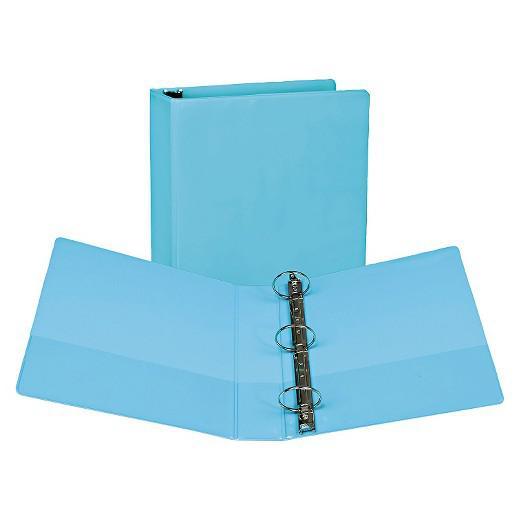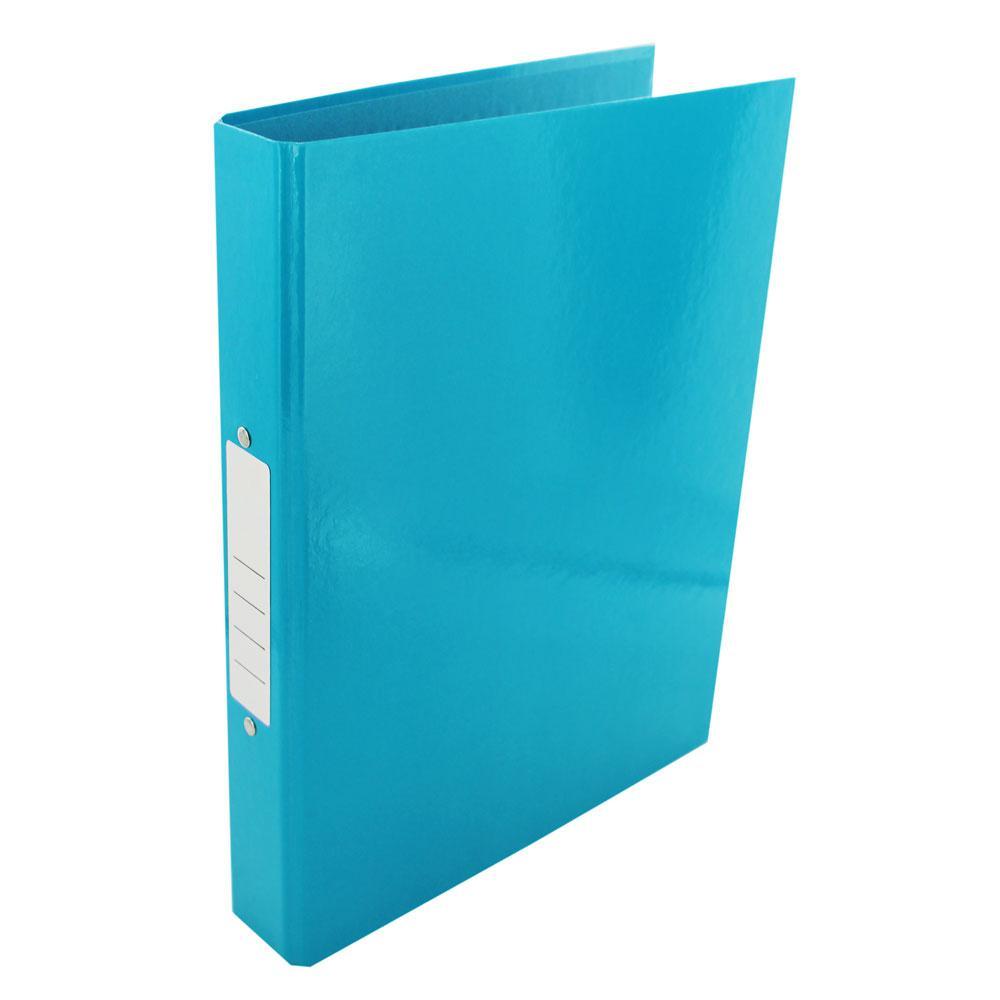The first image is the image on the left, the second image is the image on the right. Examine the images to the left and right. Is the description "In one image a blue notebook is standing on end, while the other image shows more than one notebook." accurate? Answer yes or no. Yes. The first image is the image on the left, the second image is the image on the right. Examine the images to the left and right. Is the description "At least one binder is wide open." accurate? Answer yes or no. Yes. 